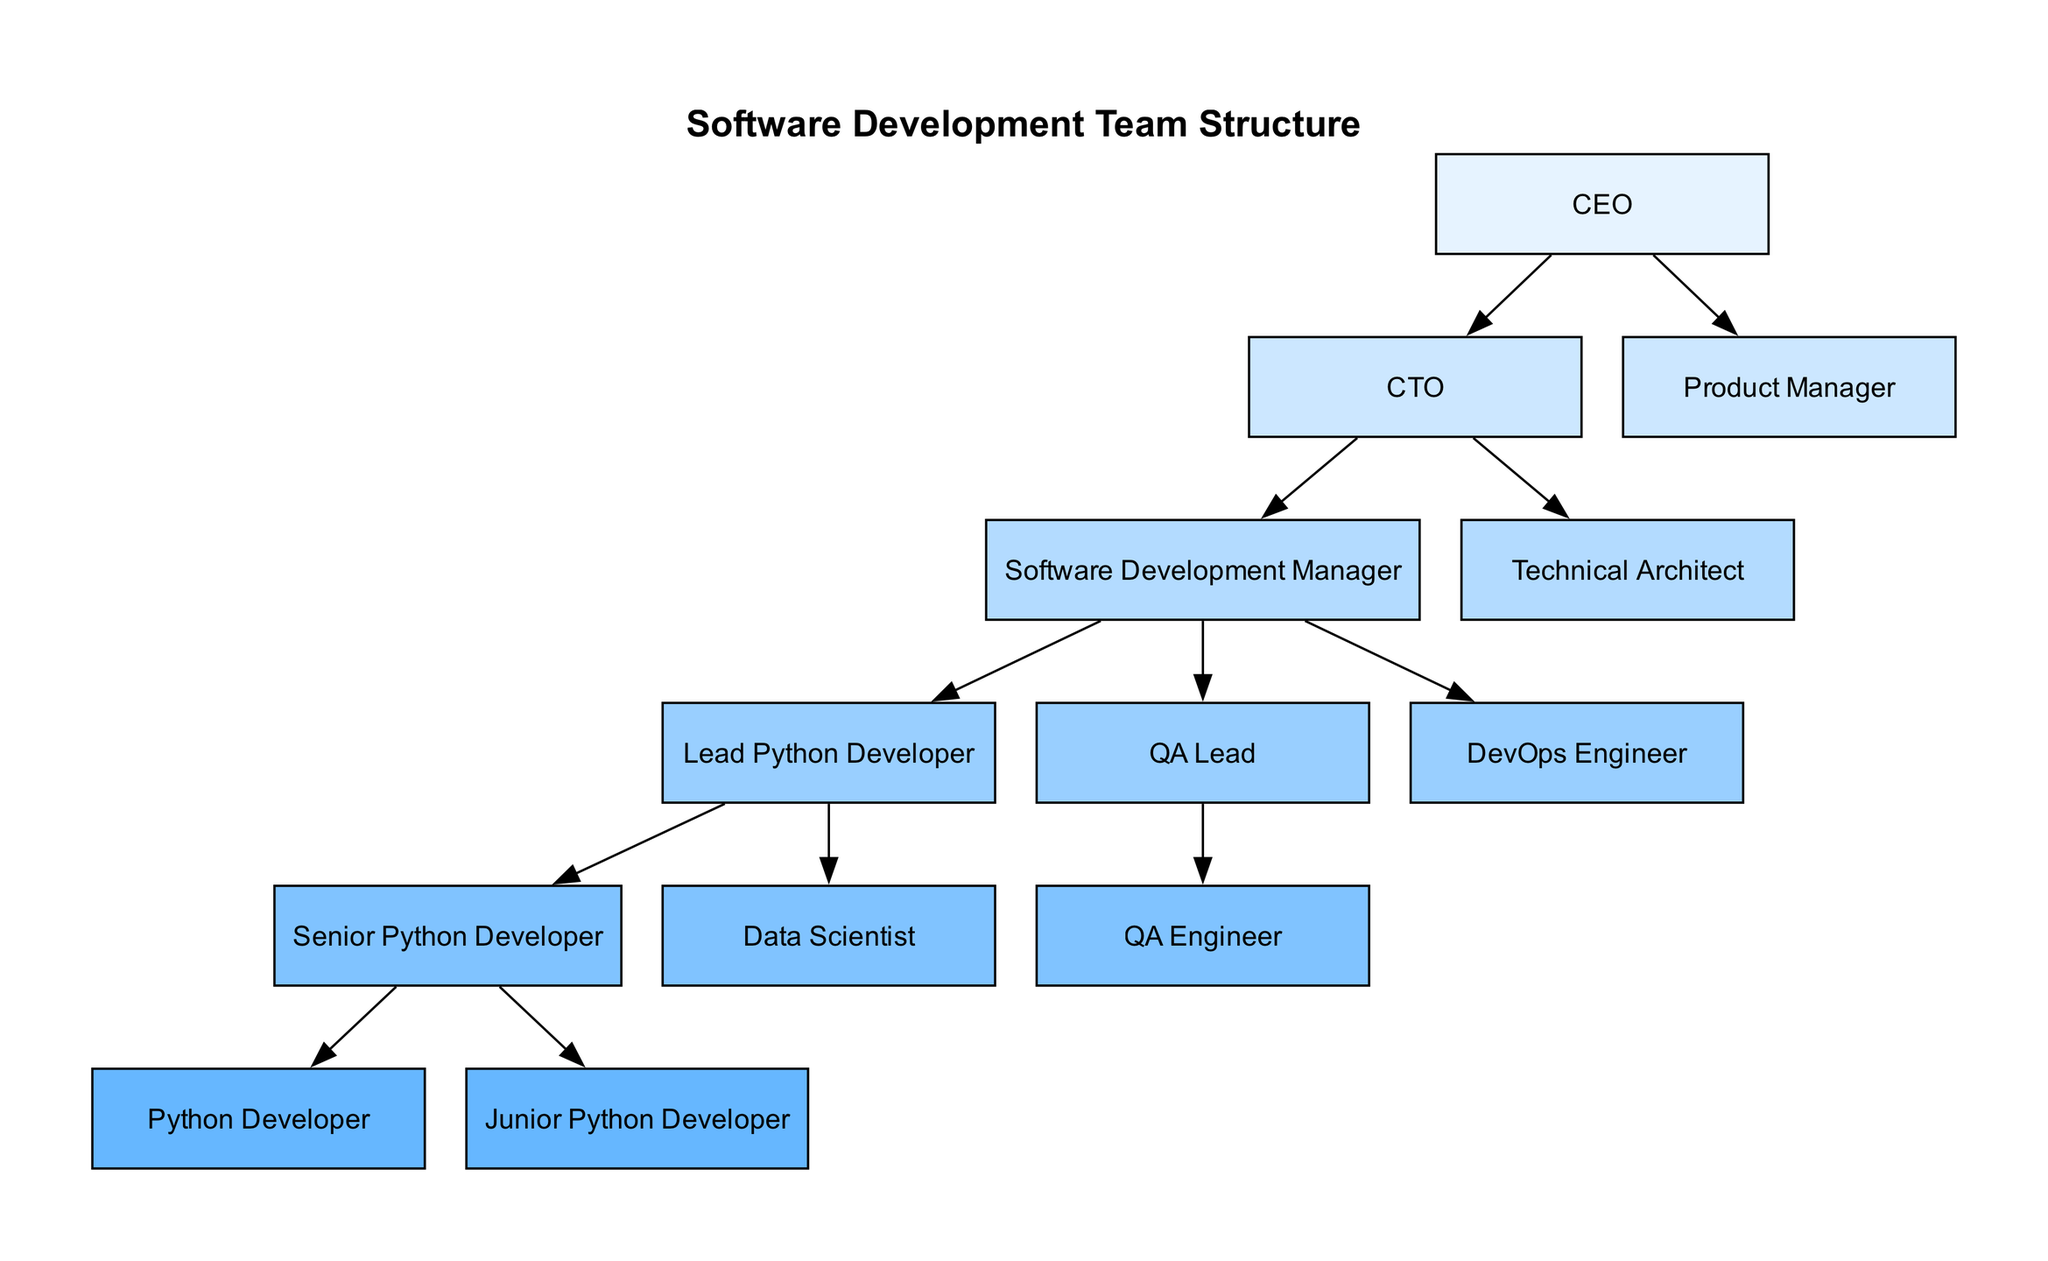What is the top role in the software development team structure? The top role in the diagram is the CEO, which is the starting point of the hierarchy.
Answer: CEO How many roles report directly to the CTO? The CTO has three roles reporting directly to them: Software Development Manager, Technical Architect, and QA Lead.
Answer: Three Who is directly below the Software Development Manager? The Software Development Manager oversees the Lead Python Developer and QA Lead, thus the immediate subordinates are the Lead Python Developer, QA Lead, and DevOps Engineer.
Answer: Lead Python Developer, QA Lead, DevOps Engineer How many total direct reports does the Lead Python Developer have? The Lead Python Developer directly manages two roles: Senior Python Developer and Data Scientist.
Answer: Two Which role is at the lowest level in the hierarchy? The lowest roles in the hierarchy are Python Developer and Junior Python Developer, as they have no one reporting to them.
Answer: Python Developer, Junior Python Developer Which role has the most subordinates? The Software Development Manager has the most direct reports, which includes the Lead Python Developer, QA Lead, and DevOps Engineer.
Answer: Software Development Manager If someone is a QA Engineer, who do they report to? The QA Engineer reports to the QA Lead, as per the structure depicted in the diagram.
Answer: QA Lead How many total roles are under the CEO? The CEO has a total of four roles under them: CTO, Product Manager, Technical Architect, and Software Development Manager.
Answer: Four What is the relationship between the Python Developer and Senior Python Developer? The Python Developer and Senior Python Developer are both subordinates to the Lead Python Developer; therefore, they report to the same role.
Answer: Both report to Lead Python Developer 